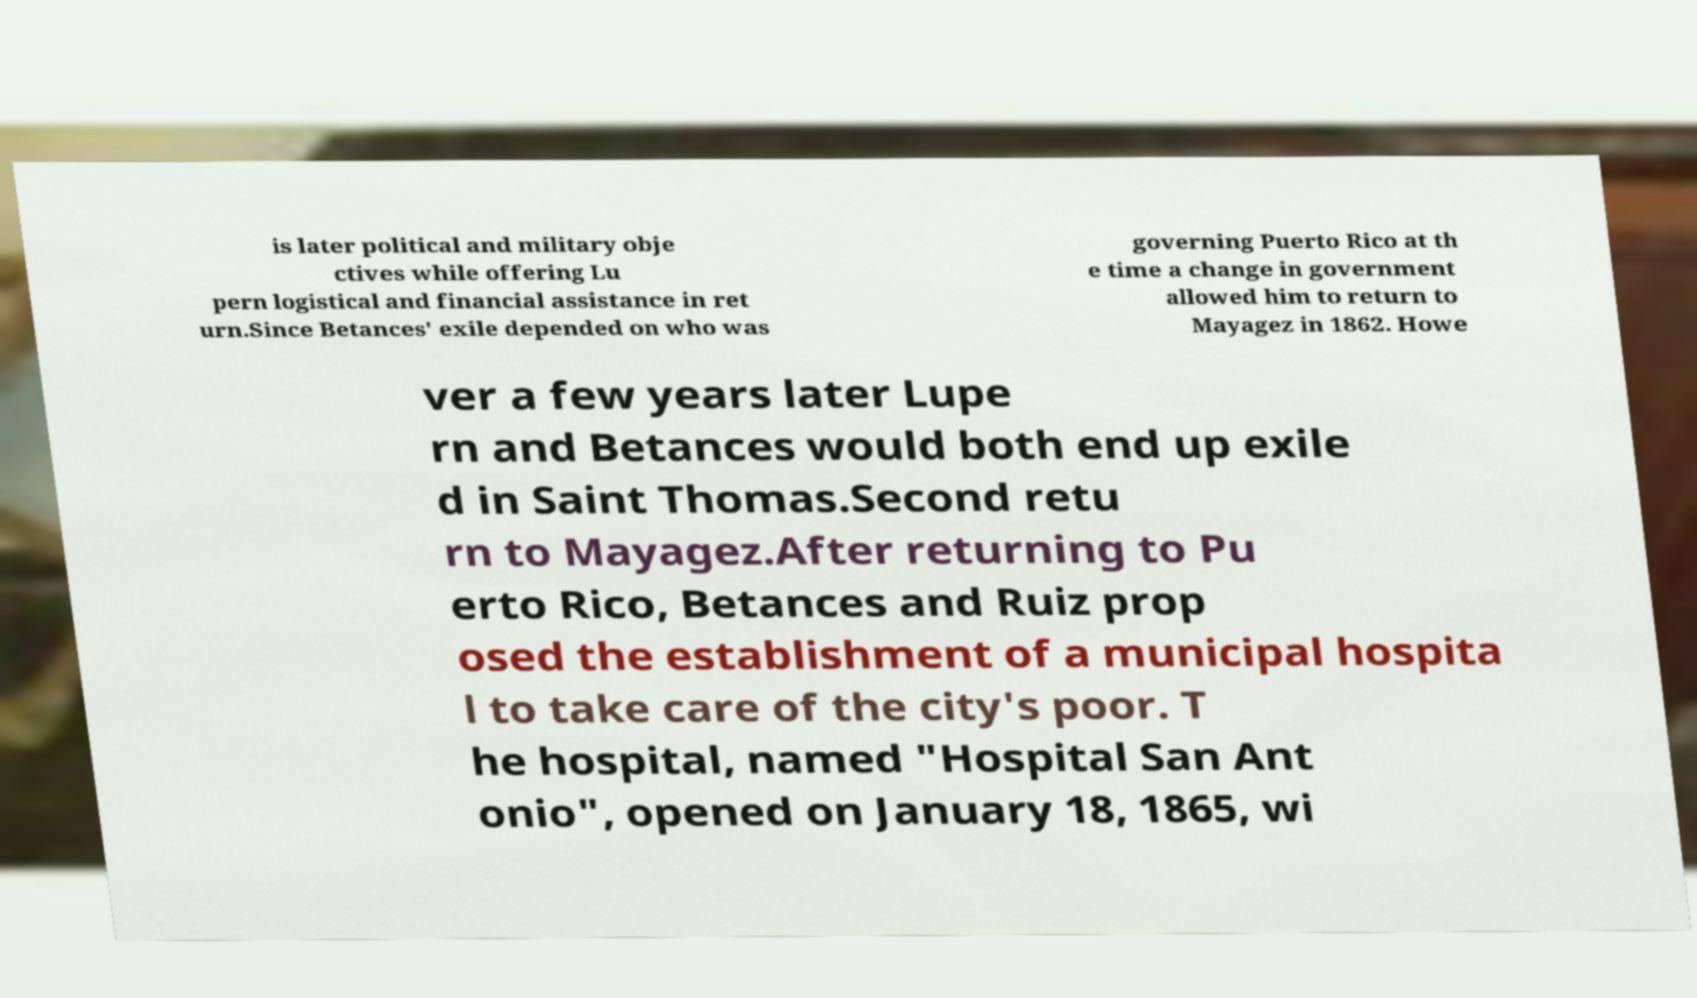Could you extract and type out the text from this image? is later political and military obje ctives while offering Lu pern logistical and financial assistance in ret urn.Since Betances' exile depended on who was governing Puerto Rico at th e time a change in government allowed him to return to Mayagez in 1862. Howe ver a few years later Lupe rn and Betances would both end up exile d in Saint Thomas.Second retu rn to Mayagez.After returning to Pu erto Rico, Betances and Ruiz prop osed the establishment of a municipal hospita l to take care of the city's poor. T he hospital, named "Hospital San Ant onio", opened on January 18, 1865, wi 